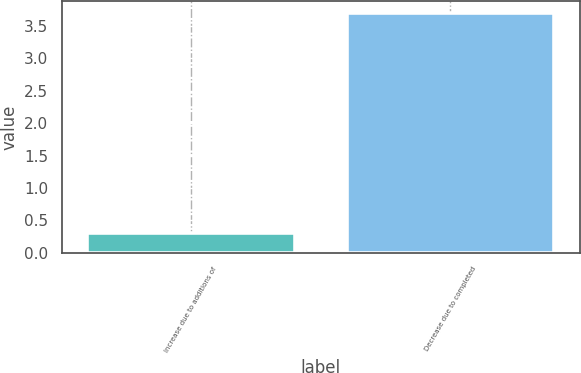Convert chart. <chart><loc_0><loc_0><loc_500><loc_500><bar_chart><fcel>Increase due to additions of<fcel>Decrease due to completed<nl><fcel>0.3<fcel>3.7<nl></chart> 